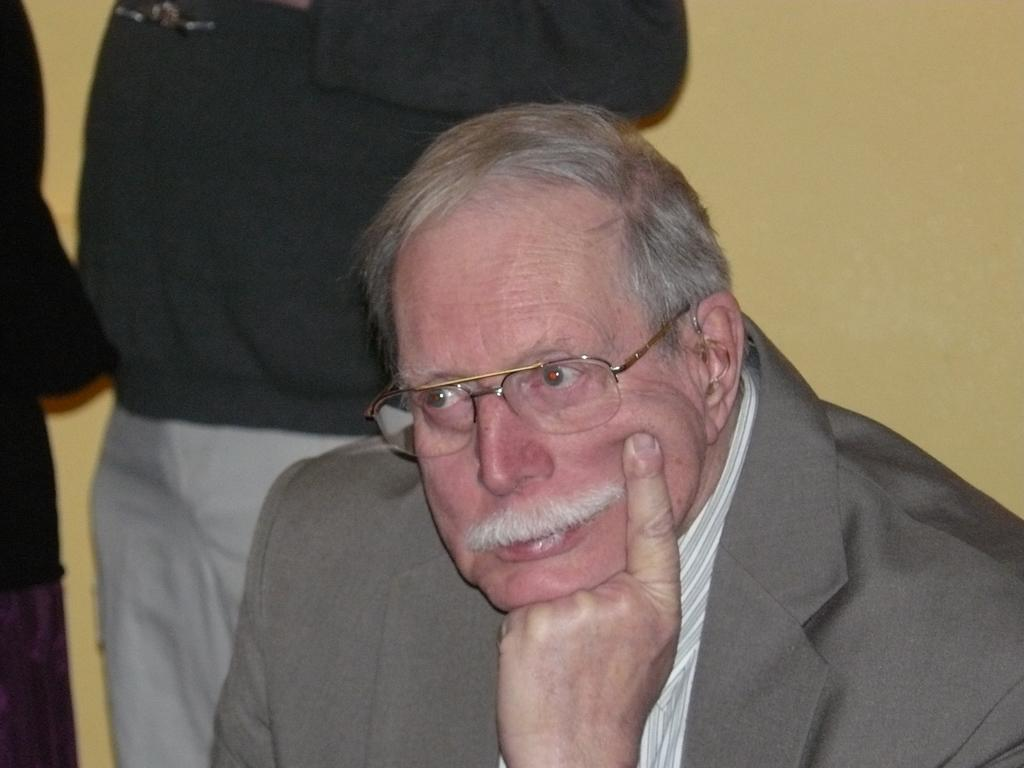Who is present in the image? There is a man in the image. What is the man wearing? The man is wearing formal dress and spectacles. Can you describe the background of the image? There are two persons and a wall visible in the background of the image. What type of meal is being prepared in the river in the image? There is no river or meal preparation present in the image. 